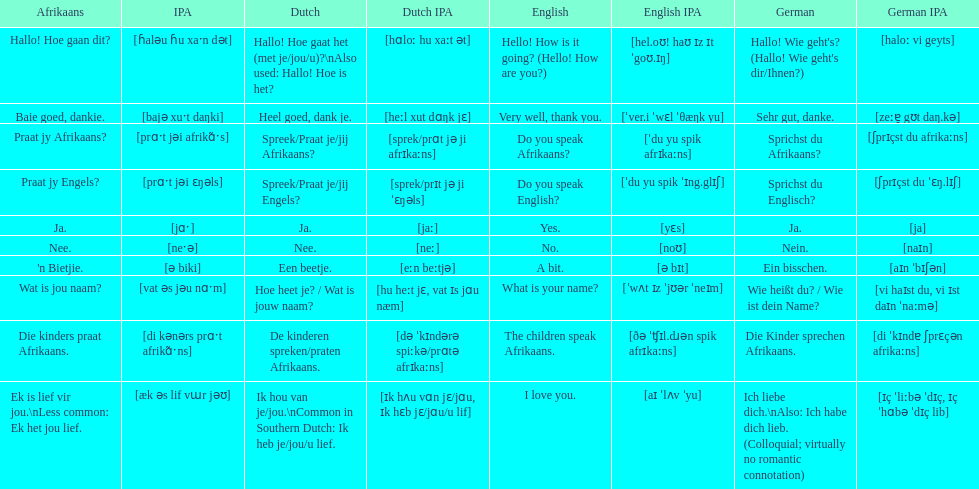Translate the following into english: 'n bietjie. A bit. 